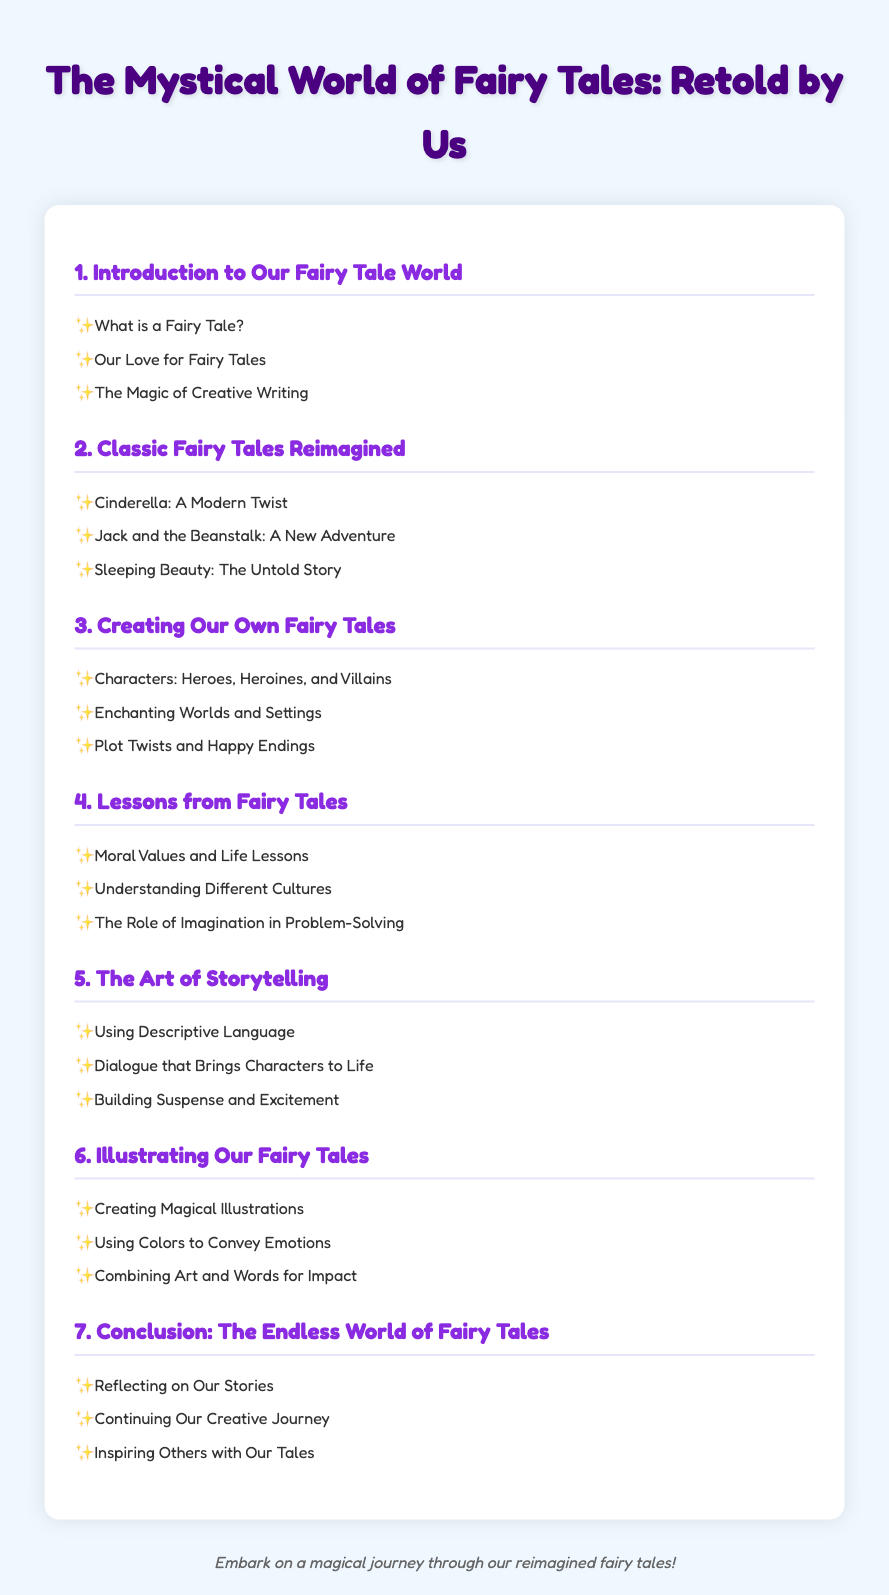What is the title of the document? The title of the document is presented prominently at the top of the page.
Answer: The Mystical World of Fairy Tales: Retold by Us How many chapters are in the document? The total number of chapters is indicated in the table of contents.
Answer: 7 What is the first chapter about? The first chapter discusses the introduction and basic concepts of fairy tales.
Answer: Introduction to Our Fairy Tale World Which fairy tale is reimagined as "A Modern Twist"? The document lists specific classic fairy tales that have been modified.
Answer: Cinderella What is the focus of Chapter 4? Chapter 4 covers lessons derived from fairy tales, emphasizing moral teachings.
Answer: Lessons from Fairy Tales What is one of the aspects discussed in "The Art of Storytelling"? This chapter highlights key storytelling techniques and styles.
Answer: Using Descriptive Language What is the last part of the document titled? The last chapter concludes the discussion and themes presented throughout the work.
Answer: Conclusion: The Endless World of Fairy Tales 